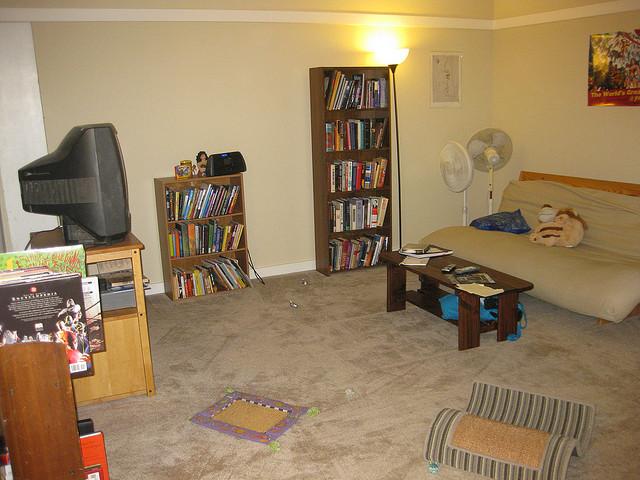Are there cat toys on the floor?
Write a very short answer. Yes. Are there any books in the room?
Give a very brief answer. Yes. What color is the rug?
Write a very short answer. Tan. What words are on the poster on the wall above the bed?
Write a very short answer. World's greatest. Is the light on?
Answer briefly. Yes. Is this a designer apartment?
Give a very brief answer. No. What color is the carpet?
Keep it brief. Beige. 